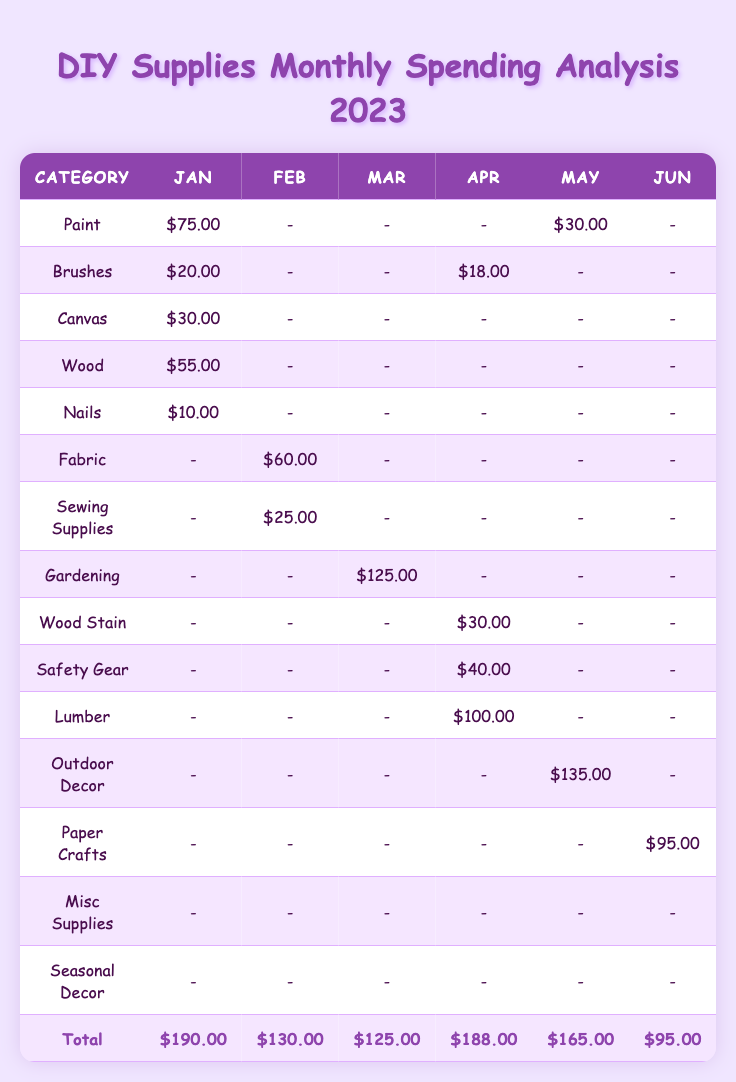What is the total amount spent on DIY supplies in March? The total amount for March is provided directly in the table, listed under the "Total" column for that month. The value is $125.00.
Answer: $125.00 How much was spent on Paint in August? The value for Paint in August can be found in the row labeled "Paint" under the August column. It shows $85.00.
Answer: $85.00 Which month had the highest spending on DIY supplies? By examining the "Total" row for all months, August shows the highest total at $210.00, which is greater than all other months.
Answer: August What was the spending on Fabric and Sewing Supplies combined in February? The total for Fabric in February is $60.00 and for Sewing Supplies is $25.00. Adding these gives $60.00 + $25.00 = $85.00.
Answer: $85.00 Did the spending on Outdoor Lighting in May exceed $50? The spending for Outdoor Lighting in May is $60.00, which is indeed greater than $50. This confirms the statement is true.
Answer: Yes What is the average spending on DIY supplies for the first quarter (January to March)? The totals for January, February, and March are $190.00, $130.00, and $125.00 respectively. The sum is $190.00 + $130.00 + $125.00 = $445.00. There are three months, so dividing gives $445.00 / 3 = $148.33.
Answer: $148.33 Which category had zero spending throughout the year? Reviewing the table shows that there are no entries listed with zero spending amounts under any category for all months. Therefore, no category fits this criterion.
Answer: None What was the total spending on seasonal projects in October and November? The total in October is $152.00 and in November is $120.00. Adding these amounts gives $152.00 + $120.00 = $272.00 for the total seasonal projects in these months.
Answer: $272.00 During which month did the spending on Gardening Tools peak? The entry for Gardening Tools in March shows $45.00, which is the only value listed under this category, indicating it peaked in that month.
Answer: March How does the total spending for December compare to November? The total for December is $160.00 and for November is $120.00. Subtracting gives $160.00 - $120.00 = $40.00, showing December's spending is $40.00 higher.
Answer: December is higher by $40.00 